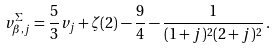<formula> <loc_0><loc_0><loc_500><loc_500>v _ { \beta , j } ^ { \Sigma } = \frac { 5 } { 3 } v _ { j } + \zeta ( 2 ) - \frac { 9 } { 4 } - \frac { 1 } { ( 1 + j ) ^ { 2 } ( 2 + j ) ^ { 2 } } \, .</formula> 